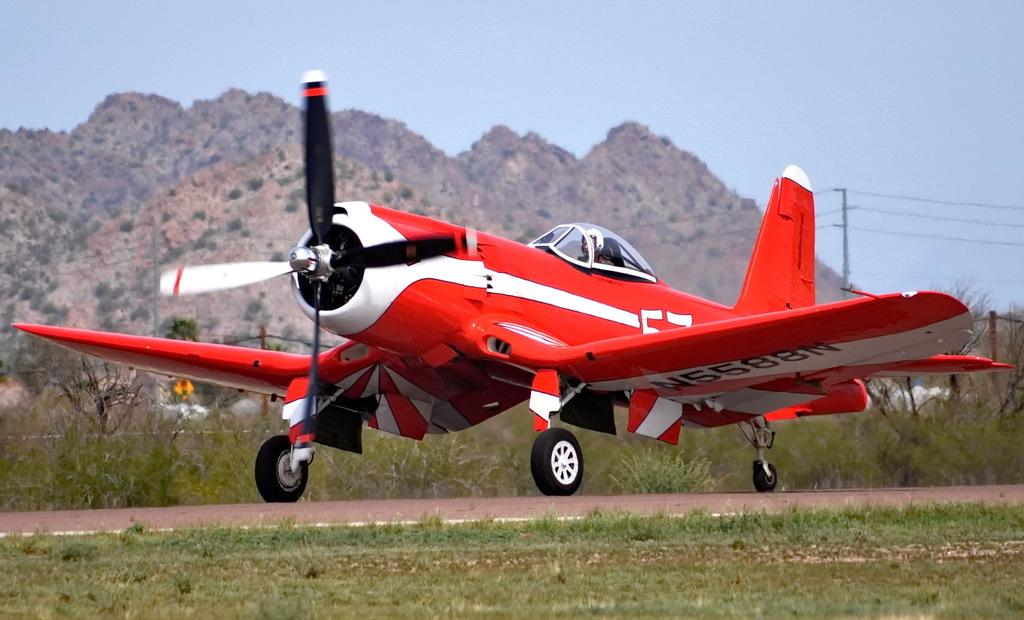<image>
Summarize the visual content of the image. A small red propeller plane is taxiing with the number N588N under the wing. 